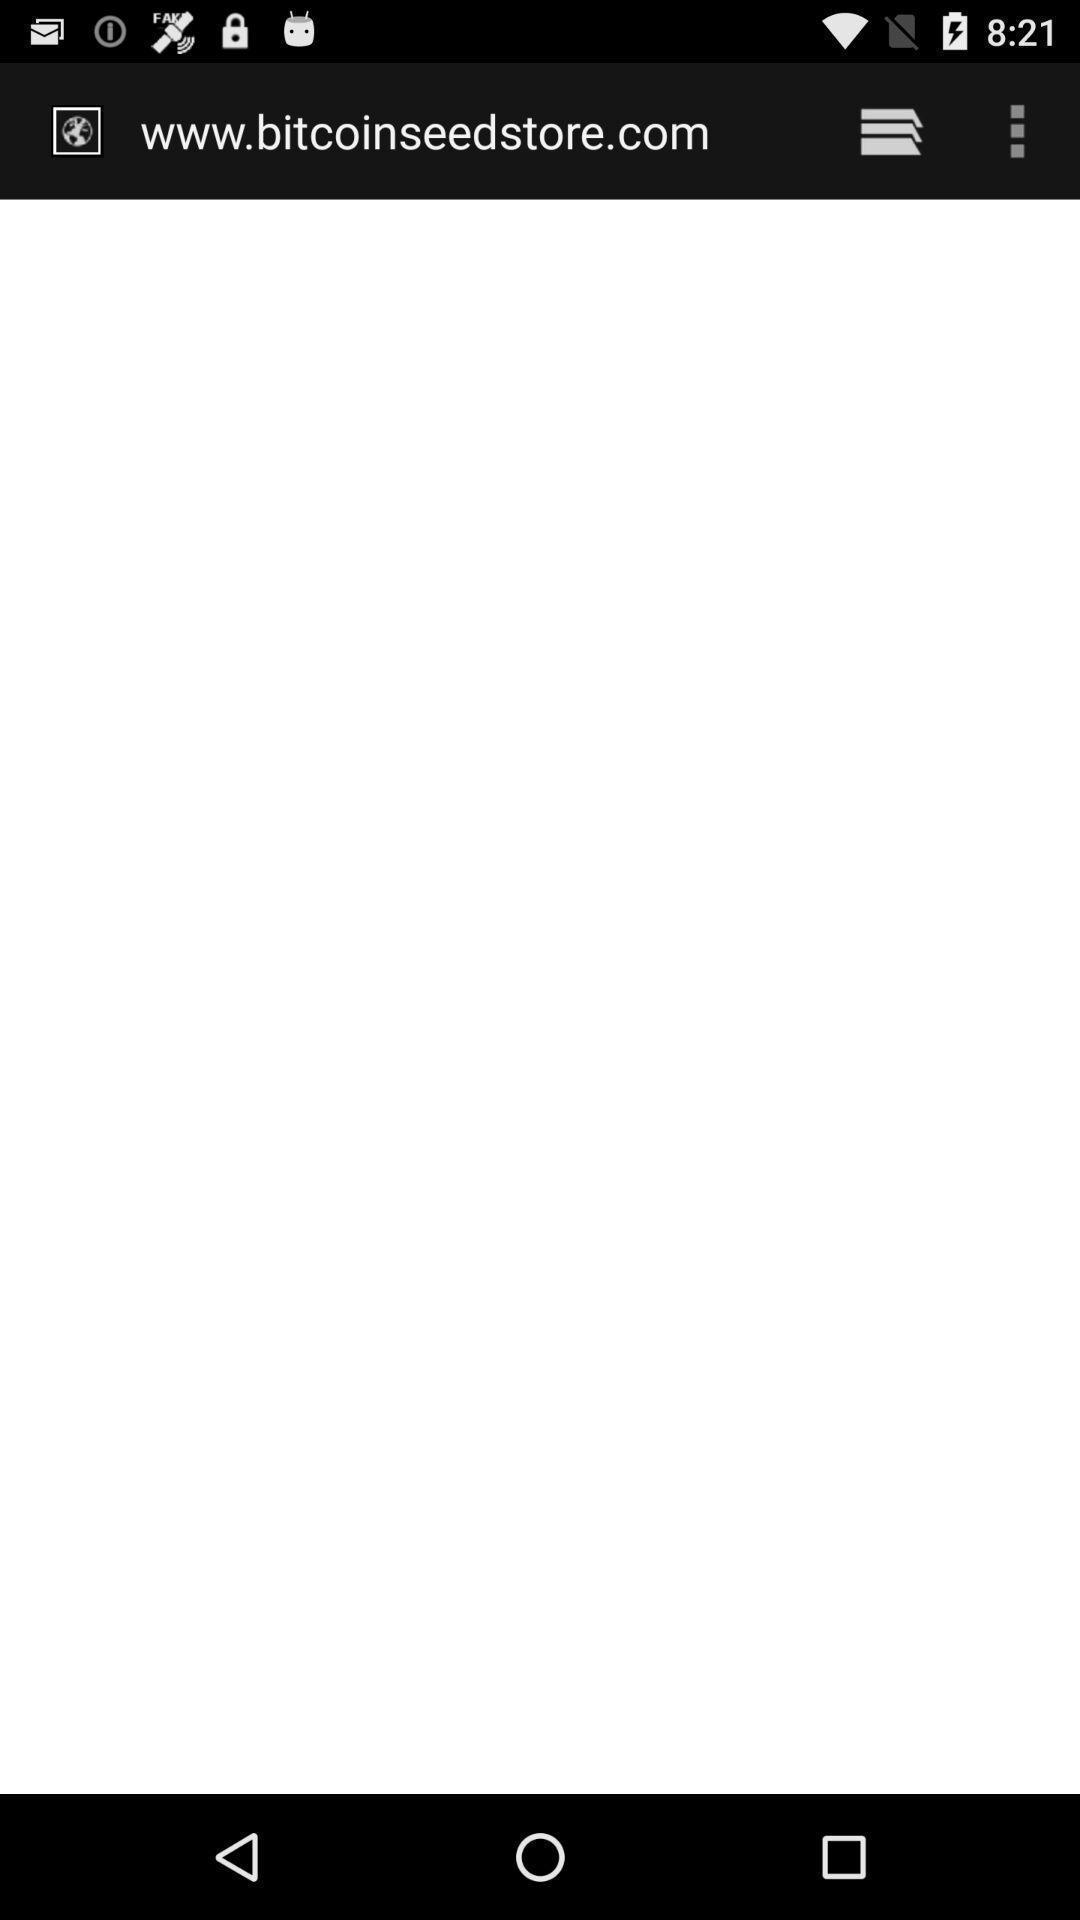Explain what's happening in this screen capture. Webpage loading of a payment network app. 